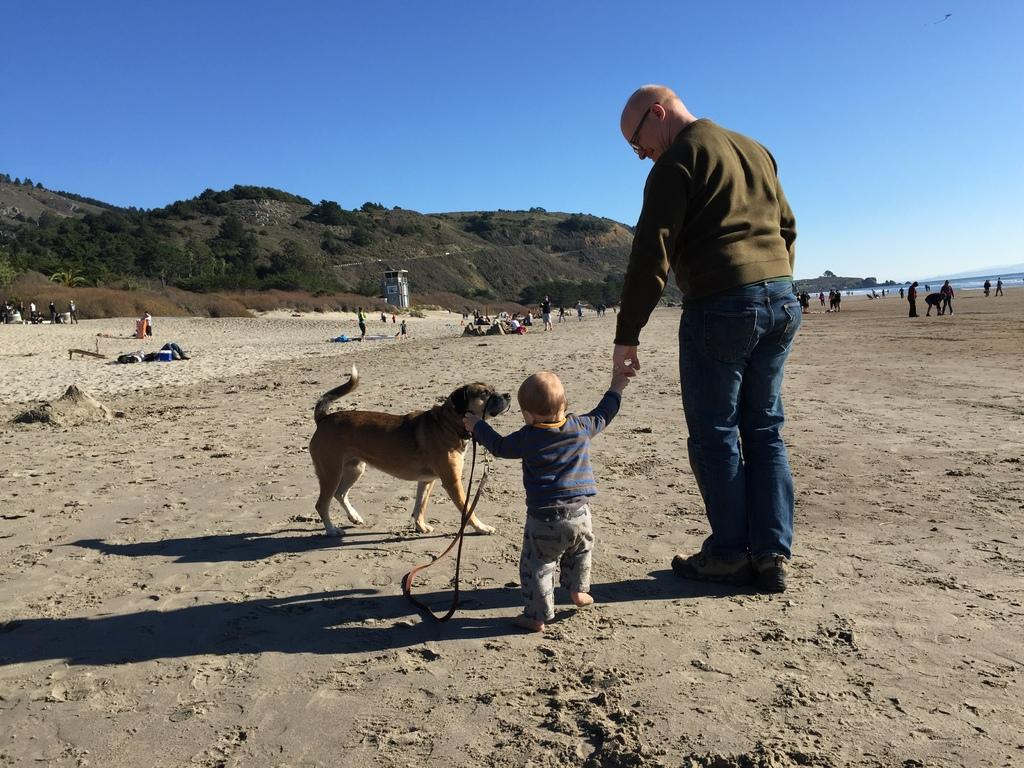Who is present in the image? There is a man and a child in the image. What other living creature can be seen in the image? There is a dog in the image. What can be seen in the background of the image? There are mountains and trees in the background of the image. What type of plantation can be seen in the image? There is no plantation present in the image; it features a man, a child, a dog, mountains, and trees. 